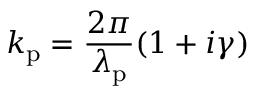<formula> <loc_0><loc_0><loc_500><loc_500>k _ { p } = \frac { 2 \pi } { \lambda _ { p } } ( 1 + i \gamma )</formula> 